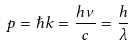<formula> <loc_0><loc_0><loc_500><loc_500>p = \hbar { k } = \frac { h \nu } { c } = \frac { h } { \lambda }</formula> 